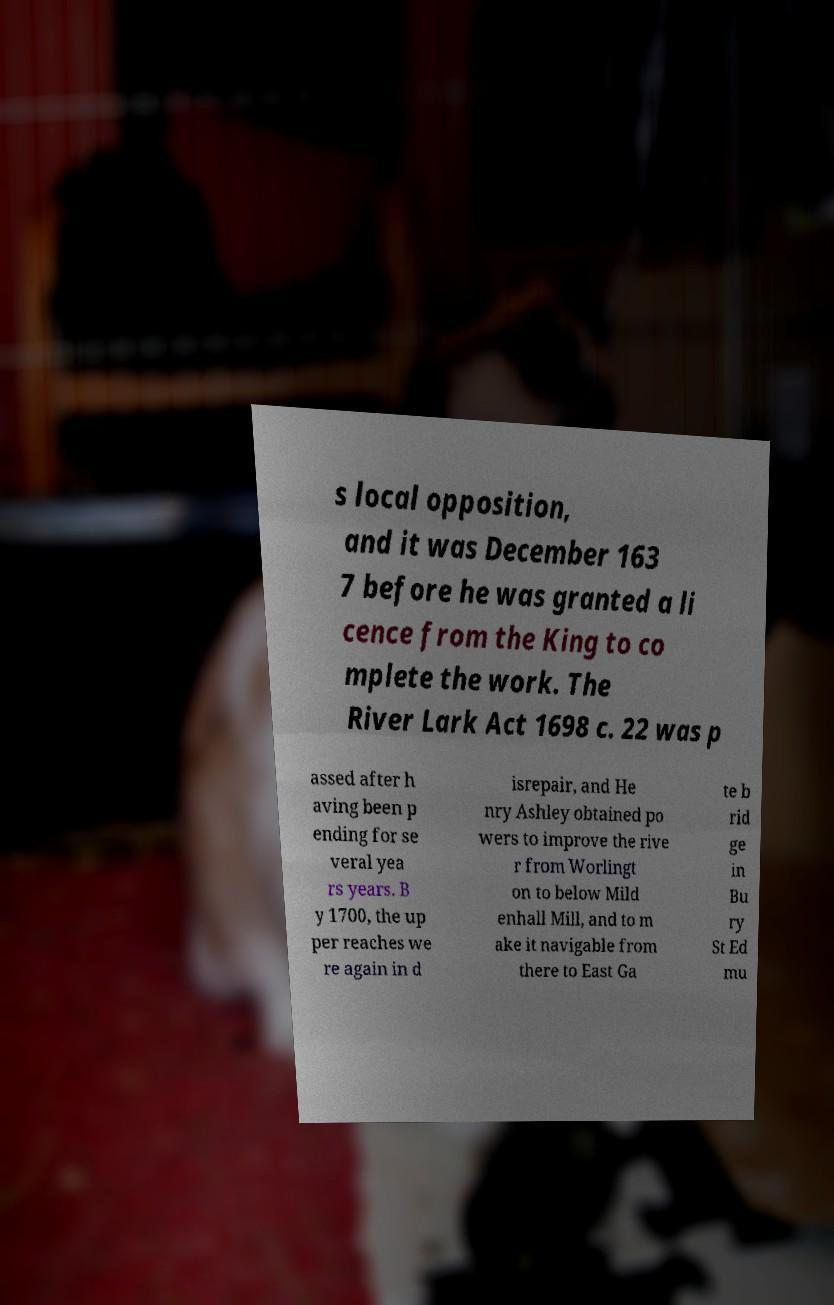Please read and relay the text visible in this image. What does it say? s local opposition, and it was December 163 7 before he was granted a li cence from the King to co mplete the work. The River Lark Act 1698 c. 22 was p assed after h aving been p ending for se veral yea rs years. B y 1700, the up per reaches we re again in d isrepair, and He nry Ashley obtained po wers to improve the rive r from Worlingt on to below Mild enhall Mill, and to m ake it navigable from there to East Ga te b rid ge in Bu ry St Ed mu 